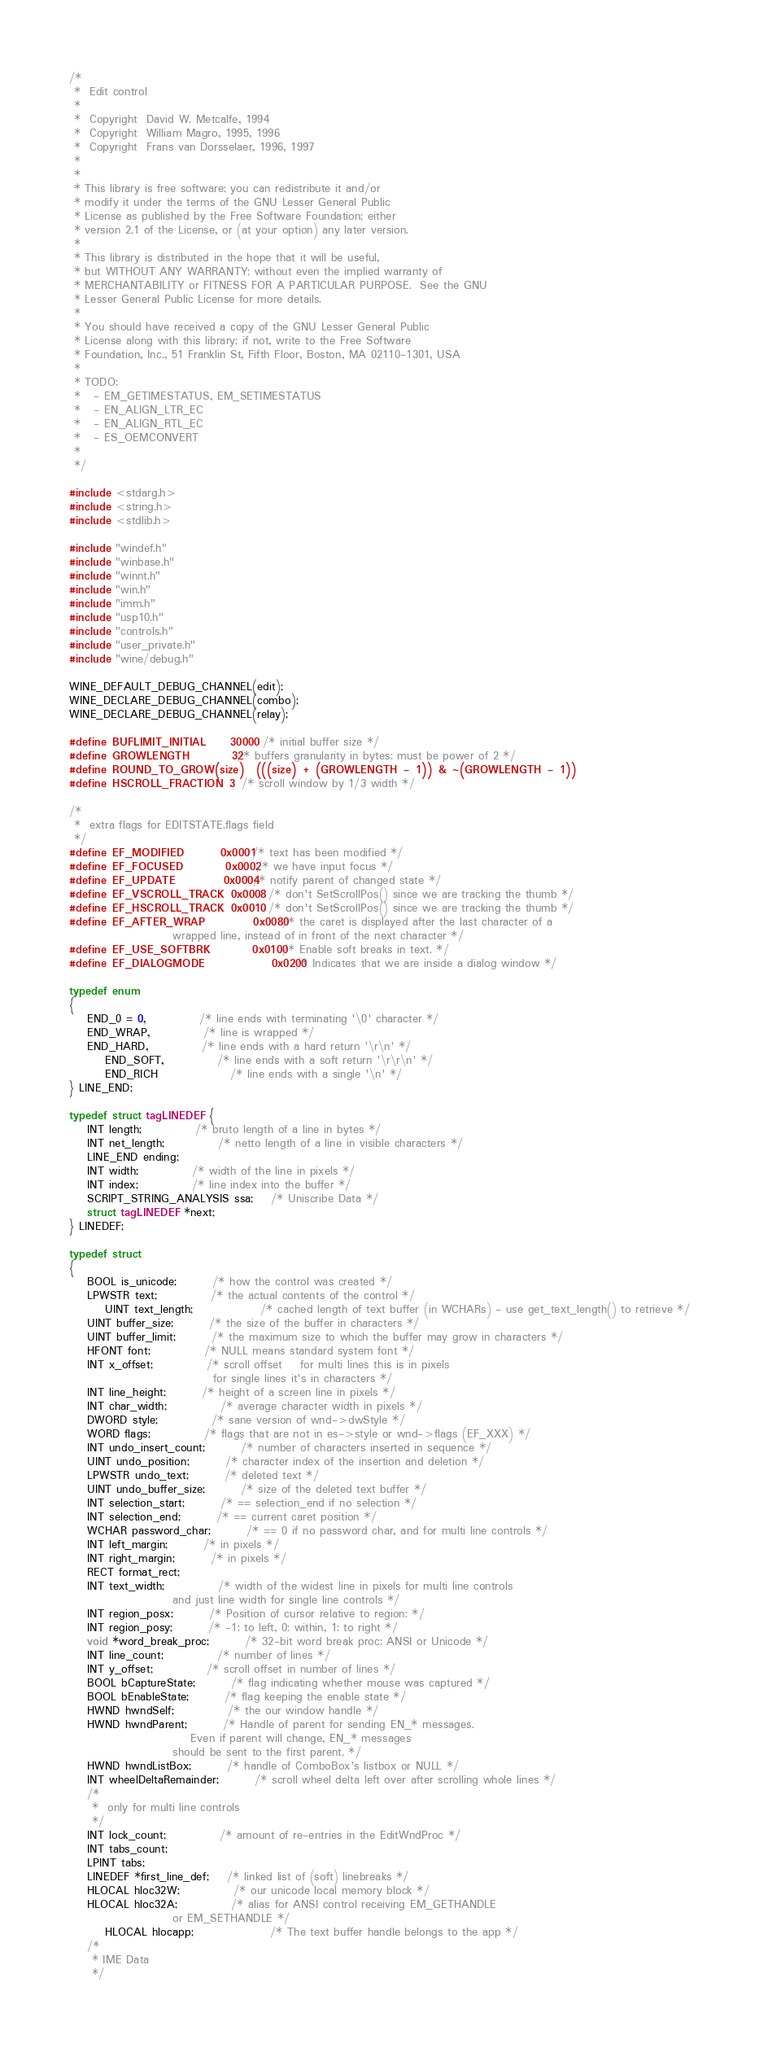Convert code to text. <code><loc_0><loc_0><loc_500><loc_500><_C_>/*
 *	Edit control
 *
 *	Copyright  David W. Metcalfe, 1994
 *	Copyright  William Magro, 1995, 1996
 *	Copyright  Frans van Dorsselaer, 1996, 1997
 *
 *
 * This library is free software; you can redistribute it and/or
 * modify it under the terms of the GNU Lesser General Public
 * License as published by the Free Software Foundation; either
 * version 2.1 of the License, or (at your option) any later version.
 *
 * This library is distributed in the hope that it will be useful,
 * but WITHOUT ANY WARRANTY; without even the implied warranty of
 * MERCHANTABILITY or FITNESS FOR A PARTICULAR PURPOSE.  See the GNU
 * Lesser General Public License for more details.
 *
 * You should have received a copy of the GNU Lesser General Public
 * License along with this library; if not, write to the Free Software
 * Foundation, Inc., 51 Franklin St, Fifth Floor, Boston, MA 02110-1301, USA
 *
 * TODO:
 *   - EM_GETIMESTATUS, EM_SETIMESTATUS
 *   - EN_ALIGN_LTR_EC
 *   - EN_ALIGN_RTL_EC
 *   - ES_OEMCONVERT
 *
 */

#include <stdarg.h>
#include <string.h>
#include <stdlib.h>

#include "windef.h"
#include "winbase.h"
#include "winnt.h"
#include "win.h"
#include "imm.h"
#include "usp10.h"
#include "controls.h"
#include "user_private.h"
#include "wine/debug.h"

WINE_DEFAULT_DEBUG_CHANNEL(edit);
WINE_DECLARE_DEBUG_CHANNEL(combo);
WINE_DECLARE_DEBUG_CHANNEL(relay);

#define BUFLIMIT_INITIAL    30000   /* initial buffer size */
#define GROWLENGTH		32	/* buffers granularity in bytes: must be power of 2 */
#define ROUND_TO_GROW(size)	(((size) + (GROWLENGTH - 1)) & ~(GROWLENGTH - 1))
#define HSCROLL_FRACTION	3	/* scroll window by 1/3 width */

/*
 *	extra flags for EDITSTATE.flags field
 */
#define EF_MODIFIED		0x0001	/* text has been modified */
#define EF_FOCUSED		0x0002	/* we have input focus */
#define EF_UPDATE		0x0004	/* notify parent of changed state */
#define EF_VSCROLL_TRACK	0x0008	/* don't SetScrollPos() since we are tracking the thumb */
#define EF_HSCROLL_TRACK	0x0010	/* don't SetScrollPos() since we are tracking the thumb */
#define EF_AFTER_WRAP		0x0080	/* the caret is displayed after the last character of a
					   wrapped line, instead of in front of the next character */
#define EF_USE_SOFTBRK		0x0100	/* Enable soft breaks in text. */
#define EF_DIALOGMODE           0x0200  /* Indicates that we are inside a dialog window */

typedef enum
{
	END_0 = 0,			/* line ends with terminating '\0' character */
	END_WRAP,			/* line is wrapped */
	END_HARD,			/* line ends with a hard return '\r\n' */
        END_SOFT,       		/* line ends with a soft return '\r\r\n' */
        END_RICH        		/* line ends with a single '\n' */
} LINE_END;

typedef struct tagLINEDEF {
	INT length;			/* bruto length of a line in bytes */
	INT net_length;			/* netto length of a line in visible characters */
	LINE_END ending;
	INT width;			/* width of the line in pixels */
	INT index; 			/* line index into the buffer */
	SCRIPT_STRING_ANALYSIS ssa;	/* Uniscribe Data */
	struct tagLINEDEF *next;
} LINEDEF;

typedef struct
{
	BOOL is_unicode;		/* how the control was created */
	LPWSTR text;			/* the actual contents of the control */
        UINT text_length;               /* cached length of text buffer (in WCHARs) - use get_text_length() to retrieve */
	UINT buffer_size;		/* the size of the buffer in characters */
	UINT buffer_limit;		/* the maximum size to which the buffer may grow in characters */
	HFONT font;			/* NULL means standard system font */
	INT x_offset;			/* scroll offset	for multi lines this is in pixels
								for single lines it's in characters */
	INT line_height;		/* height of a screen line in pixels */
	INT char_width;			/* average character width in pixels */
	DWORD style;			/* sane version of wnd->dwStyle */
	WORD flags;			/* flags that are not in es->style or wnd->flags (EF_XXX) */
	INT undo_insert_count;		/* number of characters inserted in sequence */
	UINT undo_position;		/* character index of the insertion and deletion */
	LPWSTR undo_text;		/* deleted text */
	UINT undo_buffer_size;		/* size of the deleted text buffer */
	INT selection_start;		/* == selection_end if no selection */
	INT selection_end;		/* == current caret position */
	WCHAR password_char;		/* == 0 if no password char, and for multi line controls */
	INT left_margin;		/* in pixels */
	INT right_margin;		/* in pixels */
	RECT format_rect;
	INT text_width;			/* width of the widest line in pixels for multi line controls
					   and just line width for single line controls	*/
	INT region_posx;		/* Position of cursor relative to region: */
	INT region_posy;		/* -1: to left, 0: within, 1: to right */
	void *word_break_proc;		/* 32-bit word break proc: ANSI or Unicode */
	INT line_count;			/* number of lines */
	INT y_offset;			/* scroll offset in number of lines */
	BOOL bCaptureState; 		/* flag indicating whether mouse was captured */
	BOOL bEnableState;		/* flag keeping the enable state */
	HWND hwndSelf;			/* the our window handle */
	HWND hwndParent;		/* Handle of parent for sending EN_* messages.
				           Even if parent will change, EN_* messages
					   should be sent to the first parent. */
	HWND hwndListBox;		/* handle of ComboBox's listbox or NULL */
	INT wheelDeltaRemainder;        /* scroll wheel delta left over after scrolling whole lines */
	/*
	 *	only for multi line controls
	 */
	INT lock_count;			/* amount of re-entries in the EditWndProc */
	INT tabs_count;
	LPINT tabs;
	LINEDEF *first_line_def;	/* linked list of (soft) linebreaks */
	HLOCAL hloc32W;			/* our unicode local memory block */
	HLOCAL hloc32A;			/* alias for ANSI control receiving EM_GETHANDLE
				   	   or EM_SETHANDLE */
        HLOCAL hlocapp;                 /* The text buffer handle belongs to the app */
	/*
	 * IME Data
	 */</code> 